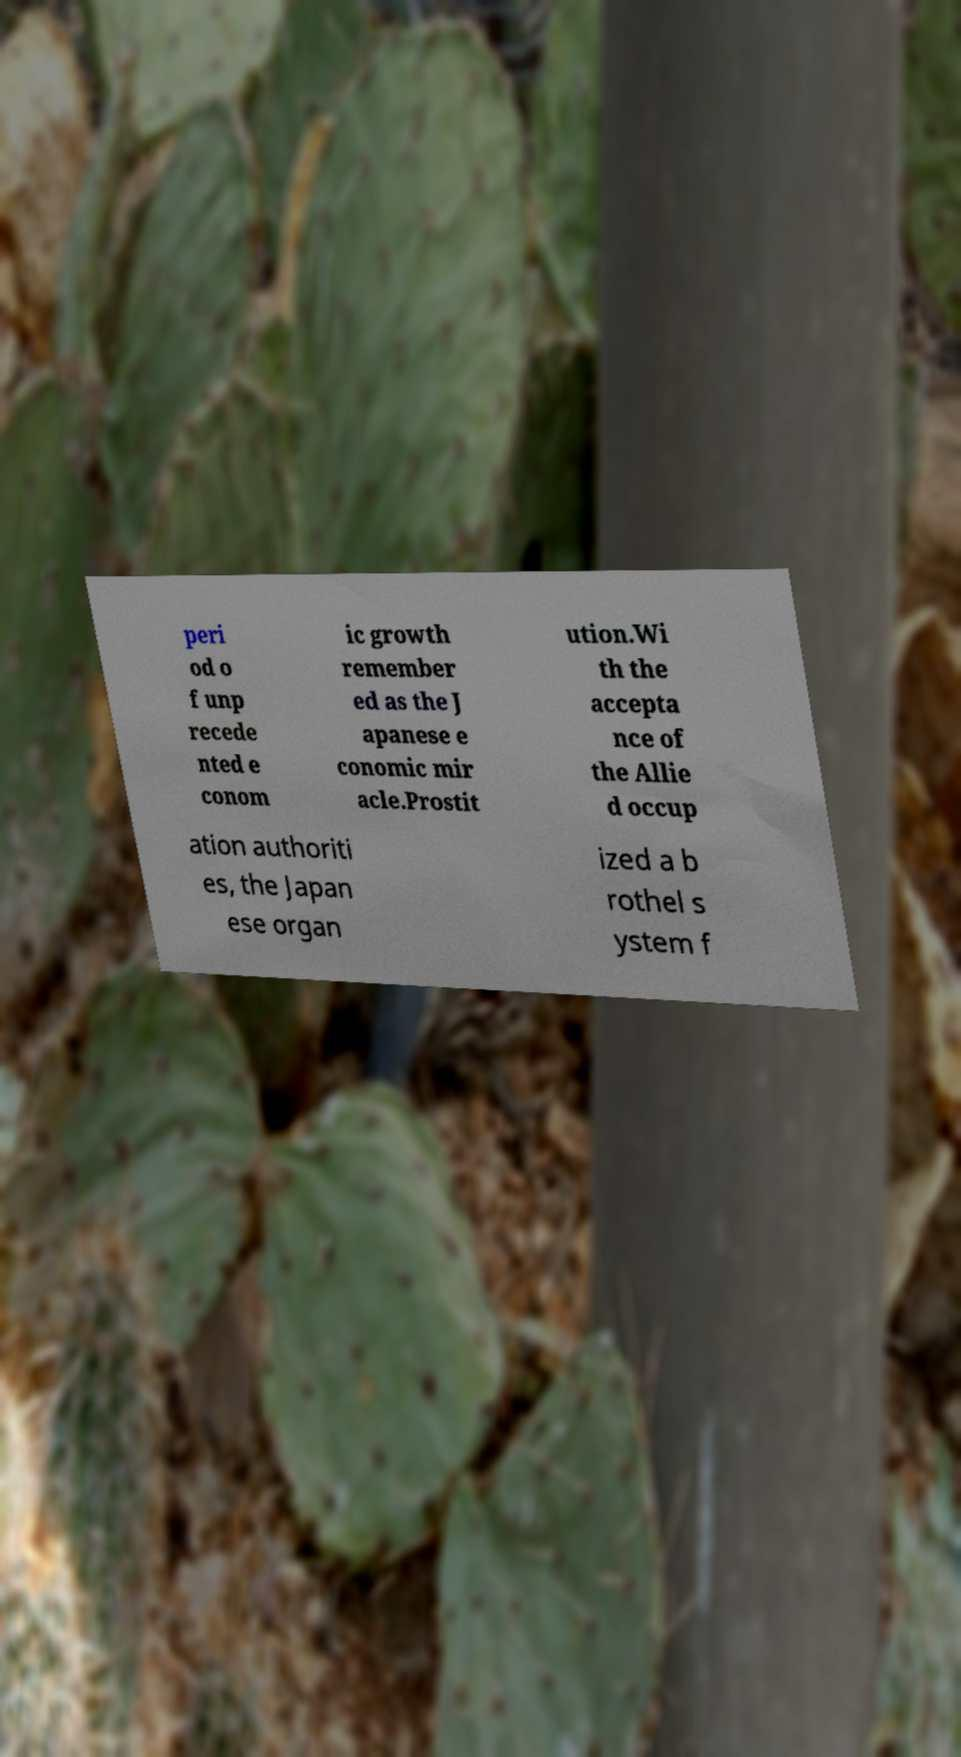Please read and relay the text visible in this image. What does it say? peri od o f unp recede nted e conom ic growth remember ed as the J apanese e conomic mir acle.Prostit ution.Wi th the accepta nce of the Allie d occup ation authoriti es, the Japan ese organ ized a b rothel s ystem f 